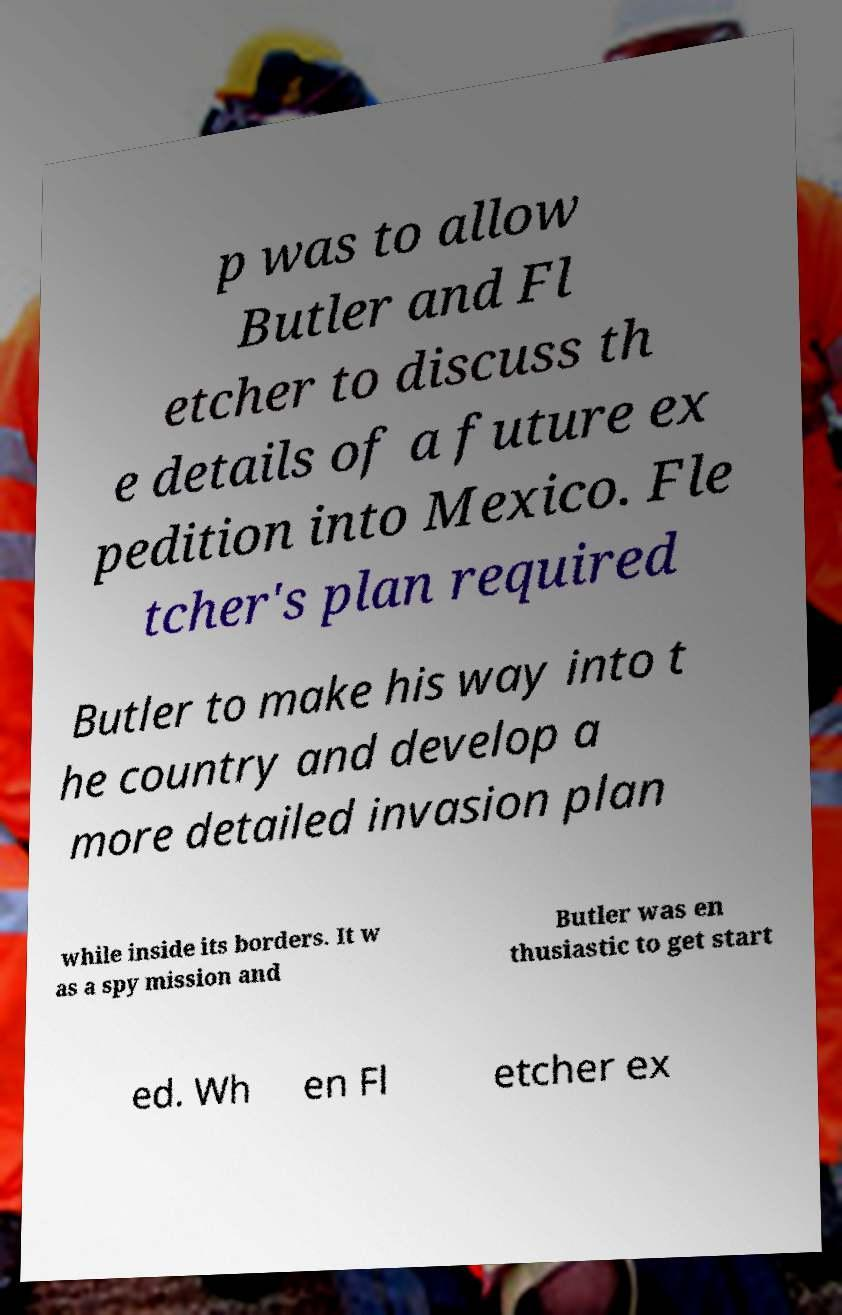Please read and relay the text visible in this image. What does it say? p was to allow Butler and Fl etcher to discuss th e details of a future ex pedition into Mexico. Fle tcher's plan required Butler to make his way into t he country and develop a more detailed invasion plan while inside its borders. It w as a spy mission and Butler was en thusiastic to get start ed. Wh en Fl etcher ex 